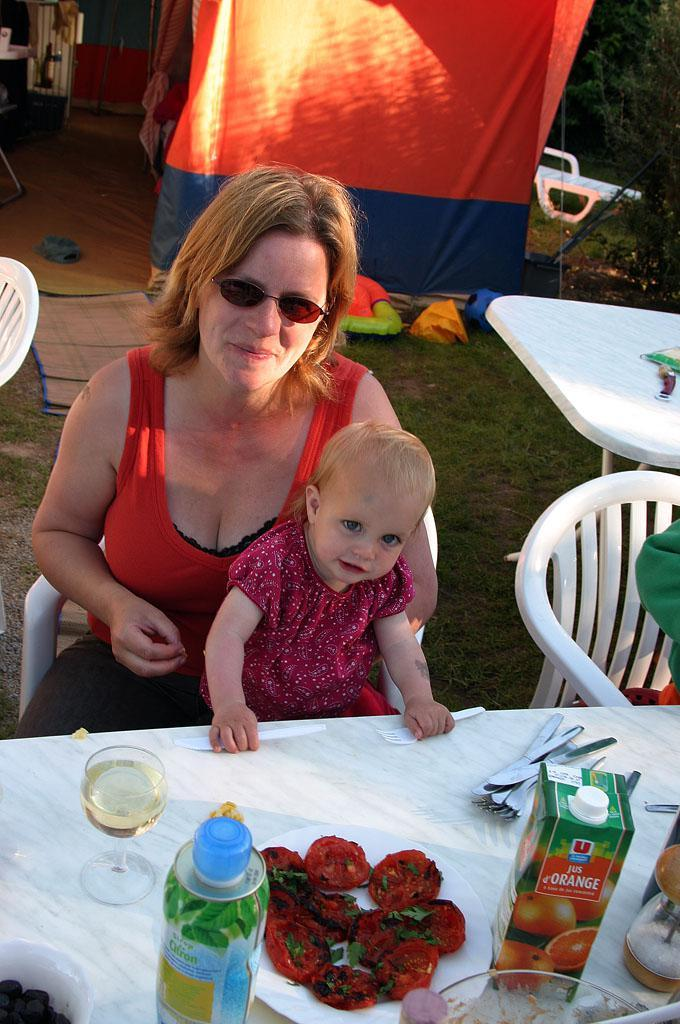Who are the people in the image? There is a lady and a little boy in the image. What is the little boy doing in the image? The little boy is sitting on the lady's lap. Where are they sitting? They are sitting in front of a table and on a chair. How many kittens are playing with a leaf on the table in the image? There are no kittens or leaves present in the image. What color is the leg of the chair they are sitting on? The image does not provide information about the color of the chair's leg. 